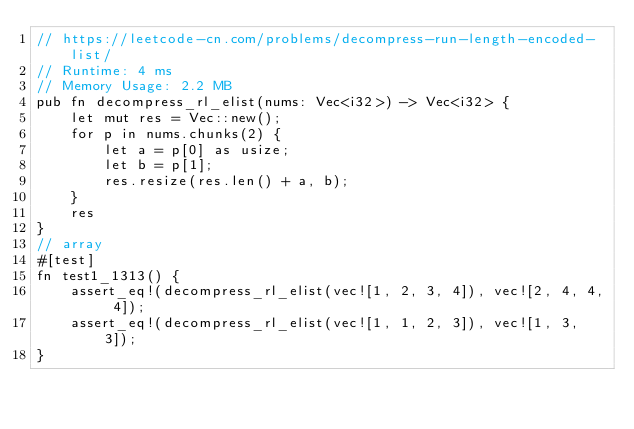<code> <loc_0><loc_0><loc_500><loc_500><_Rust_>// https://leetcode-cn.com/problems/decompress-run-length-encoded-list/
// Runtime: 4 ms
// Memory Usage: 2.2 MB
pub fn decompress_rl_elist(nums: Vec<i32>) -> Vec<i32> {
    let mut res = Vec::new();
    for p in nums.chunks(2) {
        let a = p[0] as usize;
        let b = p[1];
        res.resize(res.len() + a, b);
    }
    res
}
// array
#[test]
fn test1_1313() {
    assert_eq!(decompress_rl_elist(vec![1, 2, 3, 4]), vec![2, 4, 4, 4]);
    assert_eq!(decompress_rl_elist(vec![1, 1, 2, 3]), vec![1, 3, 3]);
}
</code> 